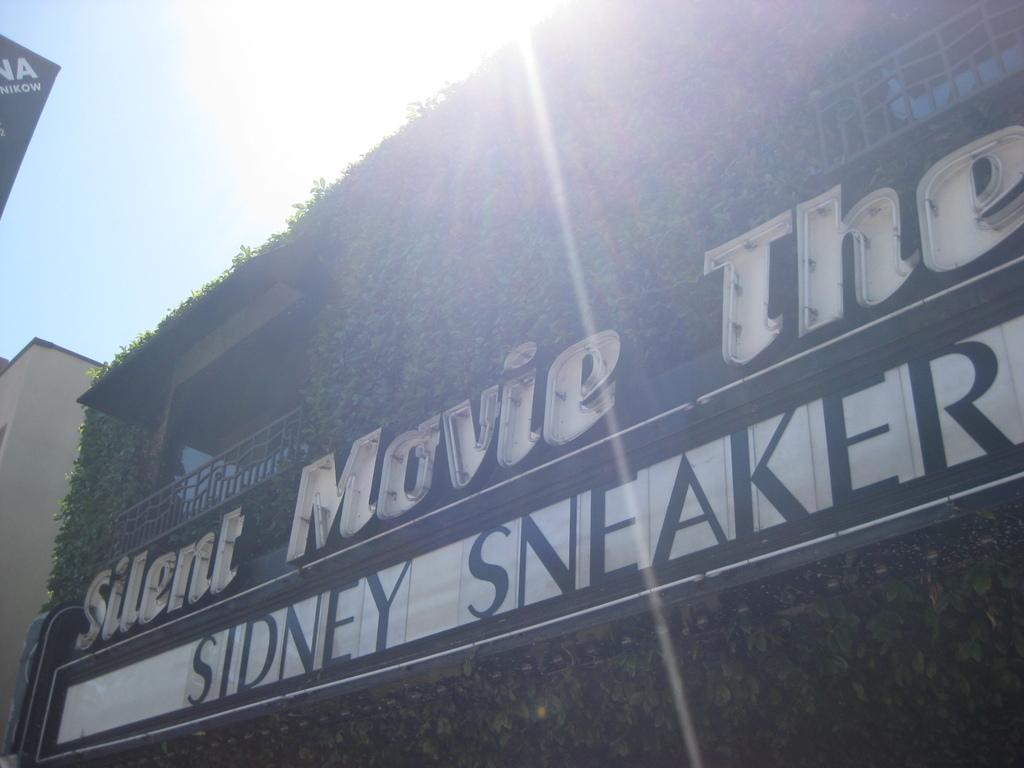<image>
Write a terse but informative summary of the picture. a billboard that says 'silent movie theatre sidney sneakers' 